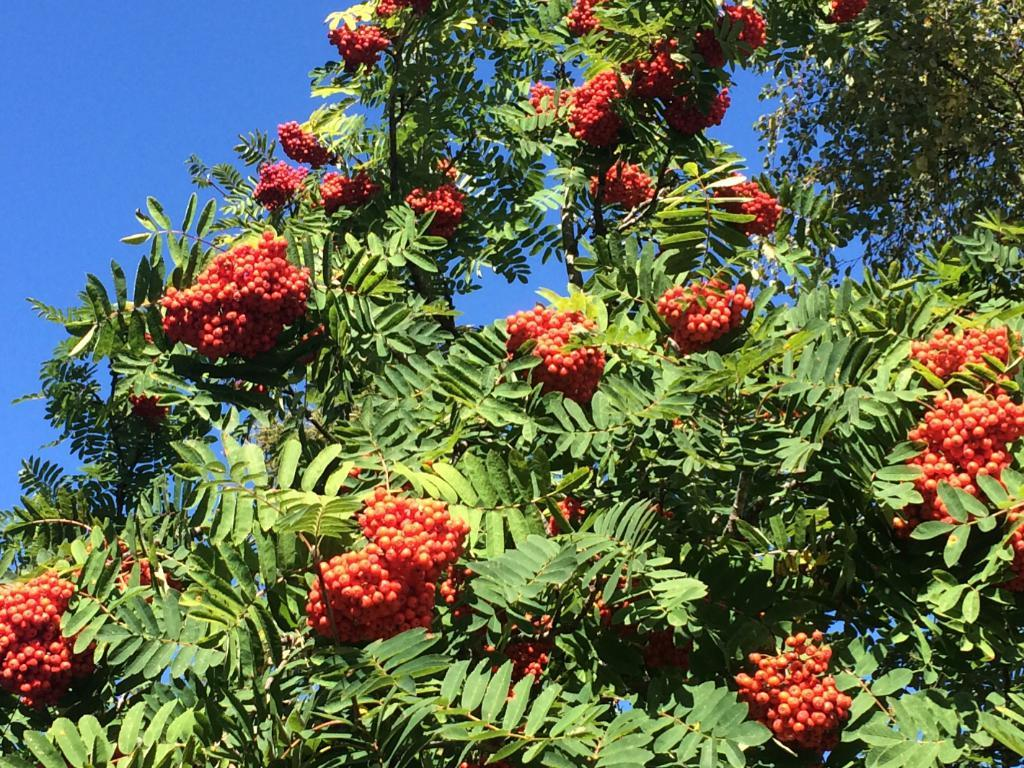What type of vegetation can be seen in the image? There are trees in the image. What color are the fruits on the trees? The fruits on the trees have an orange color. What color are the leaves on the trees? The leaves on the trees have a green color. What can be seen in the background of the image? There is a blue sky visible in the background. What type of stick is being used to lead the trees in the image? There is no stick or any indication of leading the trees in the image. The trees are stationary and not being led by any object or person. 